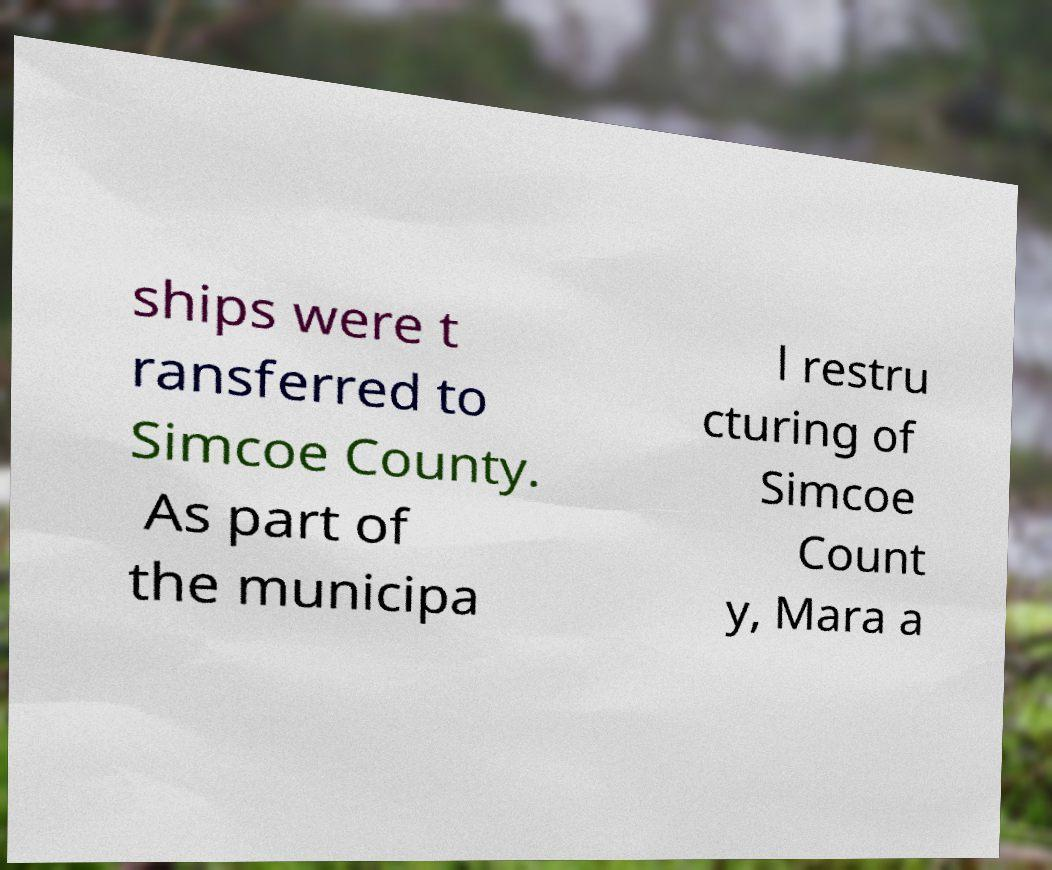What messages or text are displayed in this image? I need them in a readable, typed format. ships were t ransferred to Simcoe County. As part of the municipa l restru cturing of Simcoe Count y, Mara a 